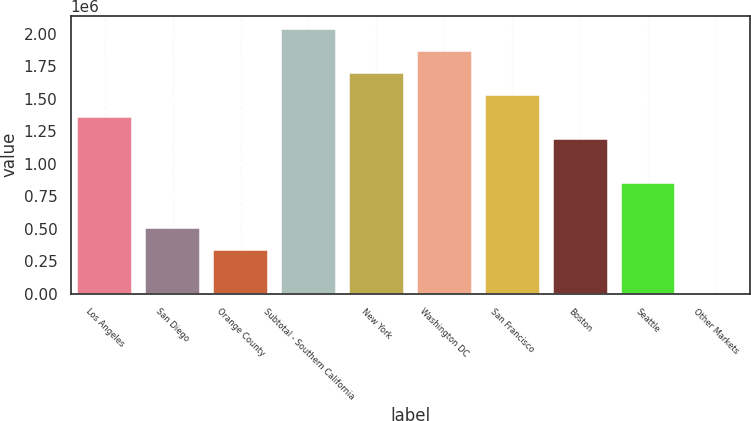Convert chart. <chart><loc_0><loc_0><loc_500><loc_500><bar_chart><fcel>Los Angeles<fcel>San Diego<fcel>Orange County<fcel>Subtotal - Southern California<fcel>New York<fcel>Washington DC<fcel>San Francisco<fcel>Boston<fcel>Seattle<fcel>Other Markets<nl><fcel>1.35866e+06<fcel>510268<fcel>340589<fcel>2.03738e+06<fcel>1.69802e+06<fcel>1.8677e+06<fcel>1.52834e+06<fcel>1.18899e+06<fcel>849626<fcel>1230<nl></chart> 